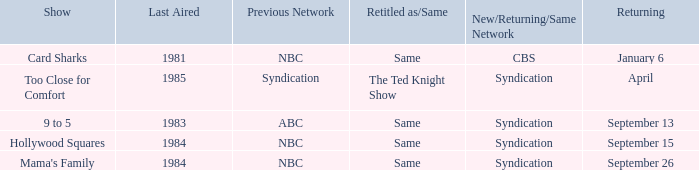When was the show 9 to 5 returning? September 13. 